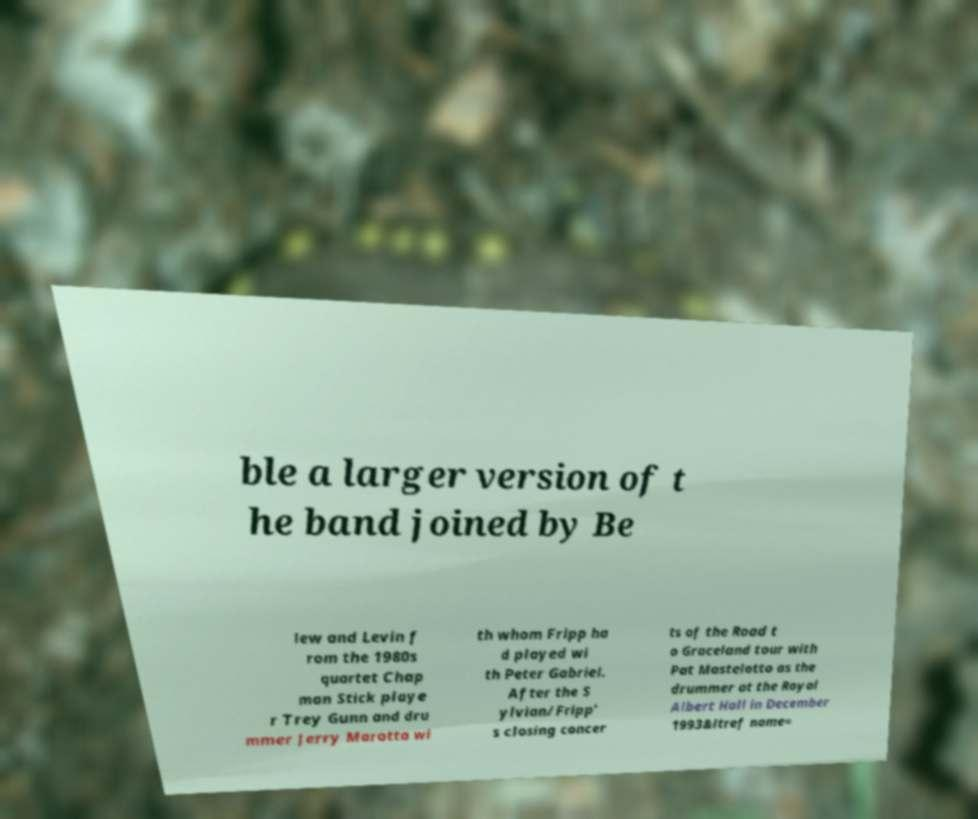Please identify and transcribe the text found in this image. ble a larger version of t he band joined by Be lew and Levin f rom the 1980s quartet Chap man Stick playe r Trey Gunn and dru mmer Jerry Marotta wi th whom Fripp ha d played wi th Peter Gabriel. After the S ylvian/Fripp' s closing concer ts of the Road t o Graceland tour with Pat Mastelotto as the drummer at the Royal Albert Hall in December 1993&ltref name= 